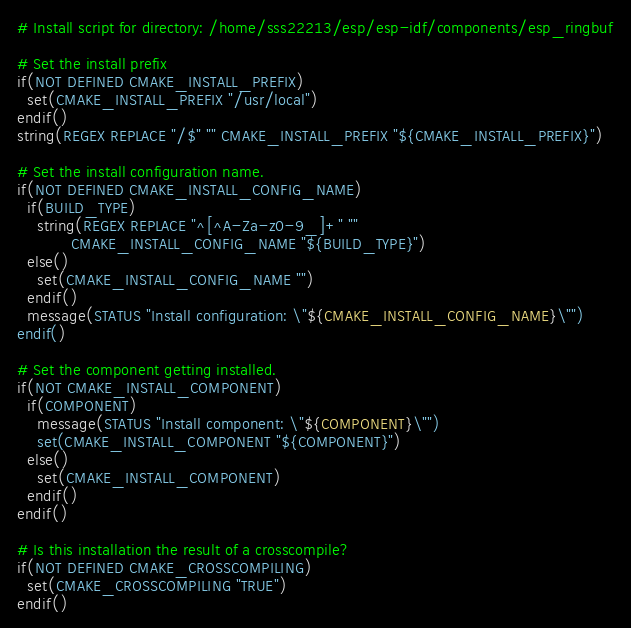<code> <loc_0><loc_0><loc_500><loc_500><_CMake_># Install script for directory: /home/sss22213/esp/esp-idf/components/esp_ringbuf

# Set the install prefix
if(NOT DEFINED CMAKE_INSTALL_PREFIX)
  set(CMAKE_INSTALL_PREFIX "/usr/local")
endif()
string(REGEX REPLACE "/$" "" CMAKE_INSTALL_PREFIX "${CMAKE_INSTALL_PREFIX}")

# Set the install configuration name.
if(NOT DEFINED CMAKE_INSTALL_CONFIG_NAME)
  if(BUILD_TYPE)
    string(REGEX REPLACE "^[^A-Za-z0-9_]+" ""
           CMAKE_INSTALL_CONFIG_NAME "${BUILD_TYPE}")
  else()
    set(CMAKE_INSTALL_CONFIG_NAME "")
  endif()
  message(STATUS "Install configuration: \"${CMAKE_INSTALL_CONFIG_NAME}\"")
endif()

# Set the component getting installed.
if(NOT CMAKE_INSTALL_COMPONENT)
  if(COMPONENT)
    message(STATUS "Install component: \"${COMPONENT}\"")
    set(CMAKE_INSTALL_COMPONENT "${COMPONENT}")
  else()
    set(CMAKE_INSTALL_COMPONENT)
  endif()
endif()

# Is this installation the result of a crosscompile?
if(NOT DEFINED CMAKE_CROSSCOMPILING)
  set(CMAKE_CROSSCOMPILING "TRUE")
endif()

</code> 